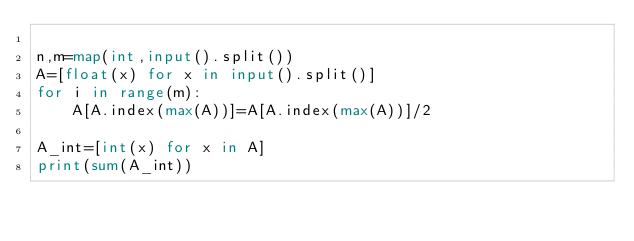Convert code to text. <code><loc_0><loc_0><loc_500><loc_500><_Python_>
n,m=map(int,input().split())
A=[float(x) for x in input().split()]
for i in range(m):
    A[A.index(max(A))]=A[A.index(max(A))]/2

A_int=[int(x) for x in A]
print(sum(A_int))
</code> 